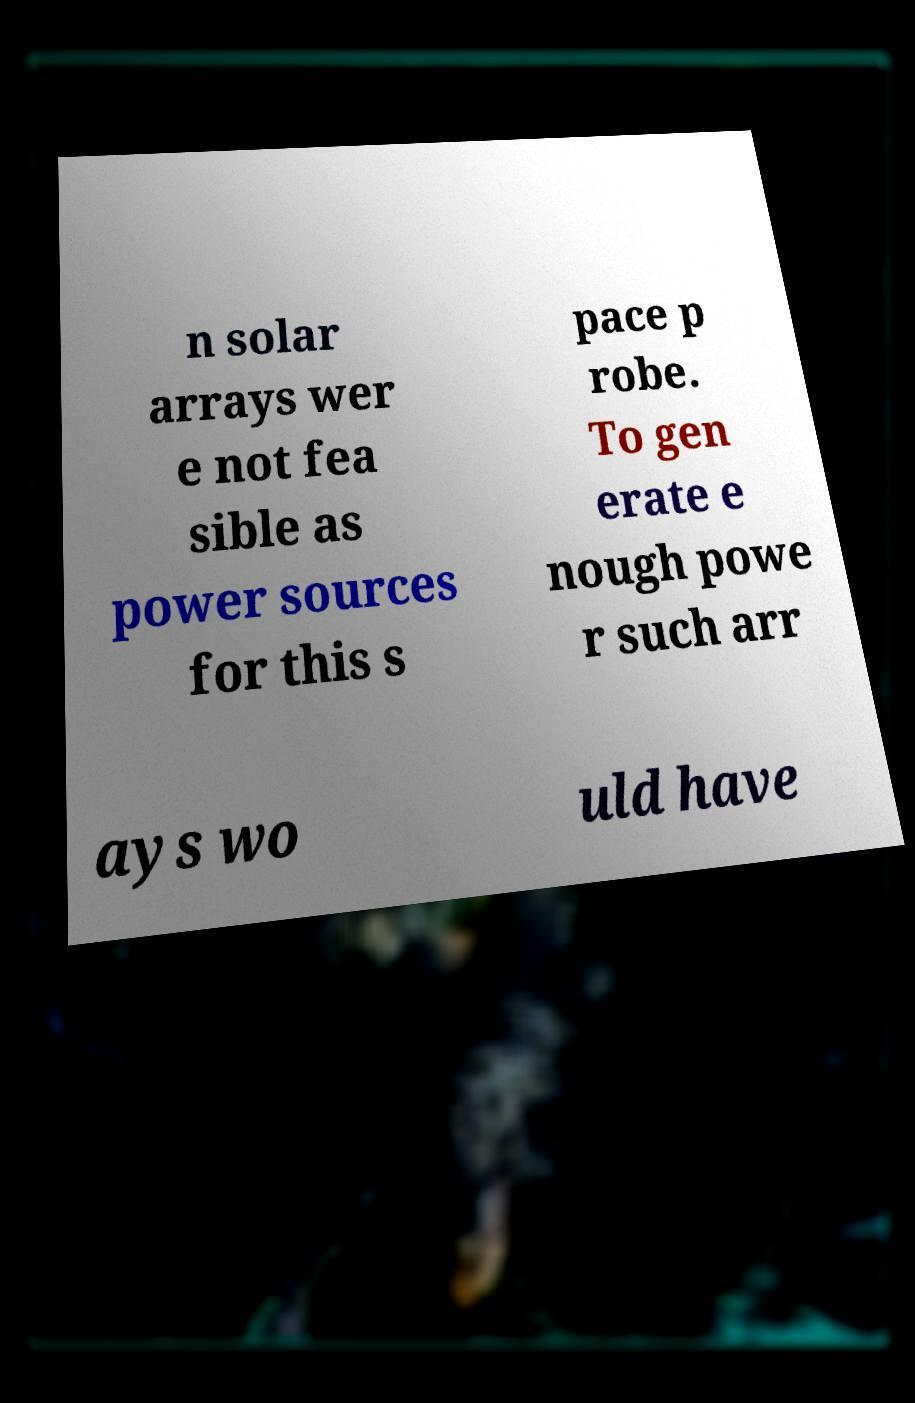What messages or text are displayed in this image? I need them in a readable, typed format. n solar arrays wer e not fea sible as power sources for this s pace p robe. To gen erate e nough powe r such arr ays wo uld have 